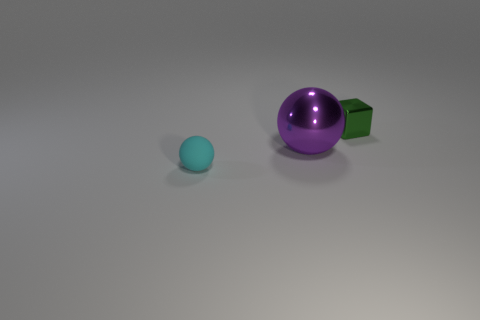Add 2 big balls. How many objects exist? 5 Subtract all spheres. How many objects are left? 1 Subtract 0 yellow blocks. How many objects are left? 3 Subtract all small spheres. Subtract all small gray rubber cylinders. How many objects are left? 2 Add 3 small metallic blocks. How many small metallic blocks are left? 4 Add 1 large red shiny objects. How many large red shiny objects exist? 1 